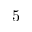<formula> <loc_0><loc_0><loc_500><loc_500>5</formula> 